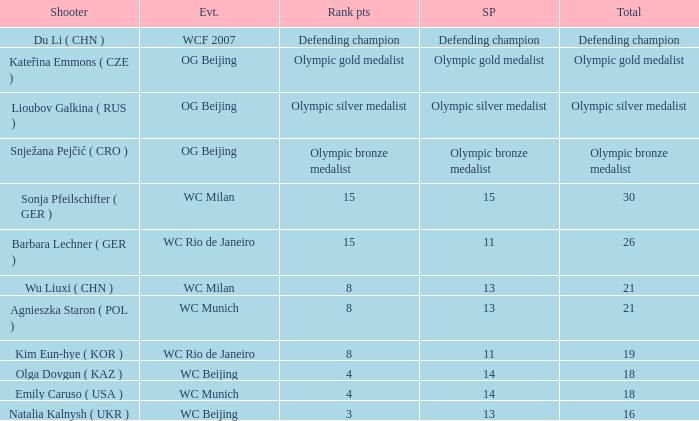Which event had a total of defending champion? WCF 2007. 